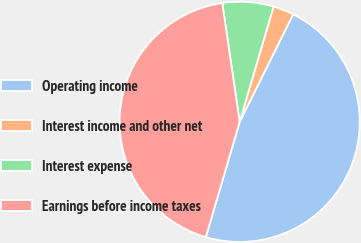Convert chart to OTSL. <chart><loc_0><loc_0><loc_500><loc_500><pie_chart><fcel>Operating income<fcel>Interest income and other net<fcel>Interest expense<fcel>Earnings before income taxes<nl><fcel>47.2%<fcel>2.8%<fcel>6.86%<fcel>43.14%<nl></chart> 